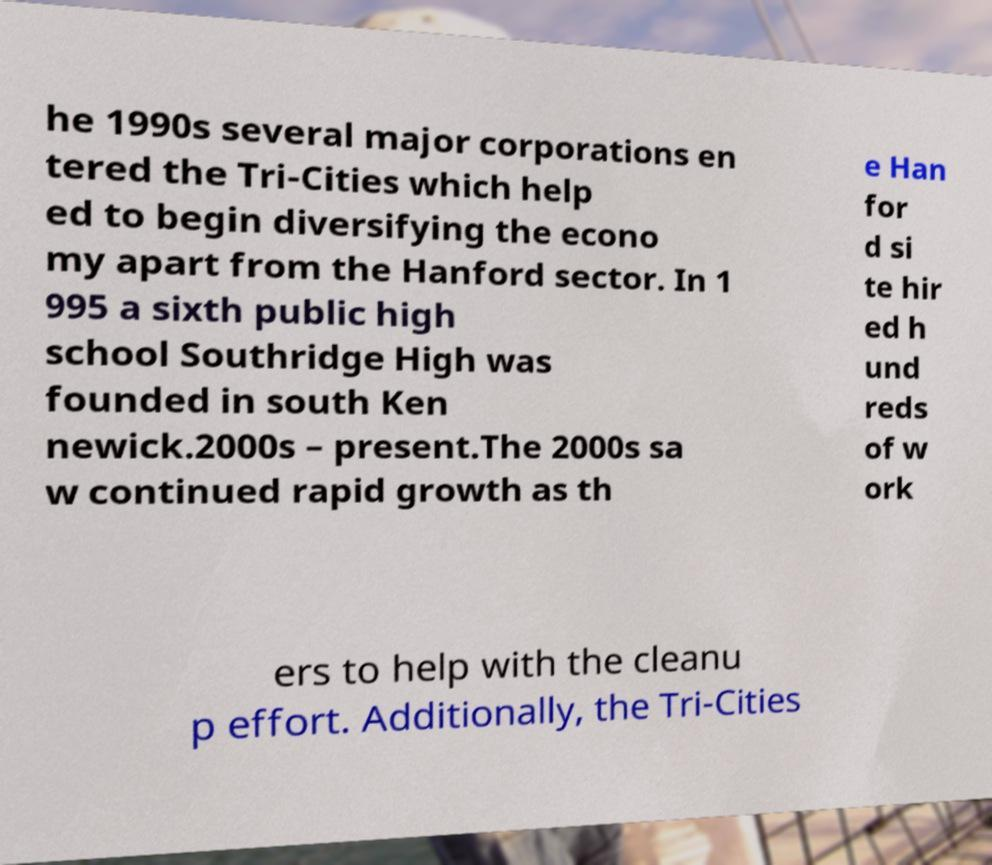Can you read and provide the text displayed in the image?This photo seems to have some interesting text. Can you extract and type it out for me? he 1990s several major corporations en tered the Tri-Cities which help ed to begin diversifying the econo my apart from the Hanford sector. In 1 995 a sixth public high school Southridge High was founded in south Ken newick.2000s – present.The 2000s sa w continued rapid growth as th e Han for d si te hir ed h und reds of w ork ers to help with the cleanu p effort. Additionally, the Tri-Cities 